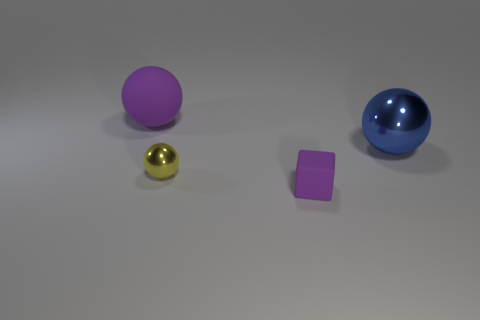What material is the thing that is behind the tiny purple block and in front of the blue sphere?
Your answer should be compact. Metal. Do the tiny cube and the big sphere to the right of the small yellow object have the same material?
Make the answer very short. No. Is there any other thing that is the same size as the yellow metal sphere?
Your answer should be compact. Yes. What number of things are small purple rubber things or rubber objects that are in front of the big blue metallic sphere?
Offer a very short reply. 1. There is a purple thing that is behind the small sphere; is it the same size as the rubber thing that is on the right side of the yellow thing?
Provide a short and direct response. No. How many other objects are the same color as the tiny rubber thing?
Provide a succinct answer. 1. There is a yellow metallic sphere; does it have the same size as the thing that is right of the small purple matte block?
Give a very brief answer. No. There is a metallic ball in front of the big ball that is in front of the large purple object; what size is it?
Offer a very short reply. Small. There is another big metal object that is the same shape as the yellow shiny thing; what is its color?
Your answer should be very brief. Blue. Is the purple cube the same size as the yellow sphere?
Make the answer very short. Yes. 